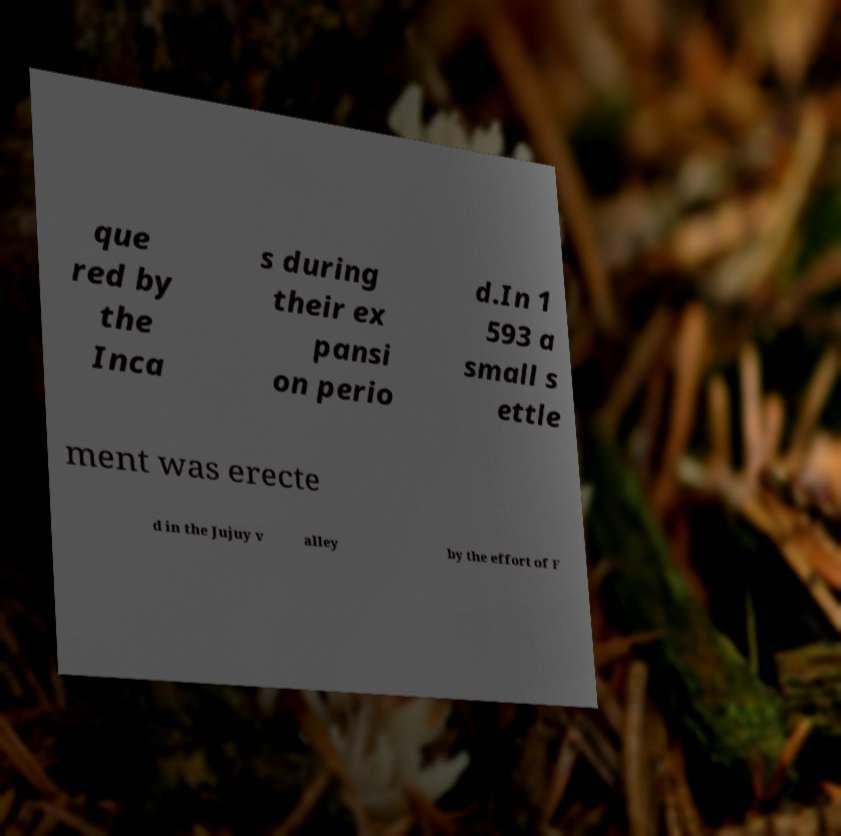There's text embedded in this image that I need extracted. Can you transcribe it verbatim? que red by the Inca s during their ex pansi on perio d.In 1 593 a small s ettle ment was erecte d in the Jujuy v alley by the effort of F 